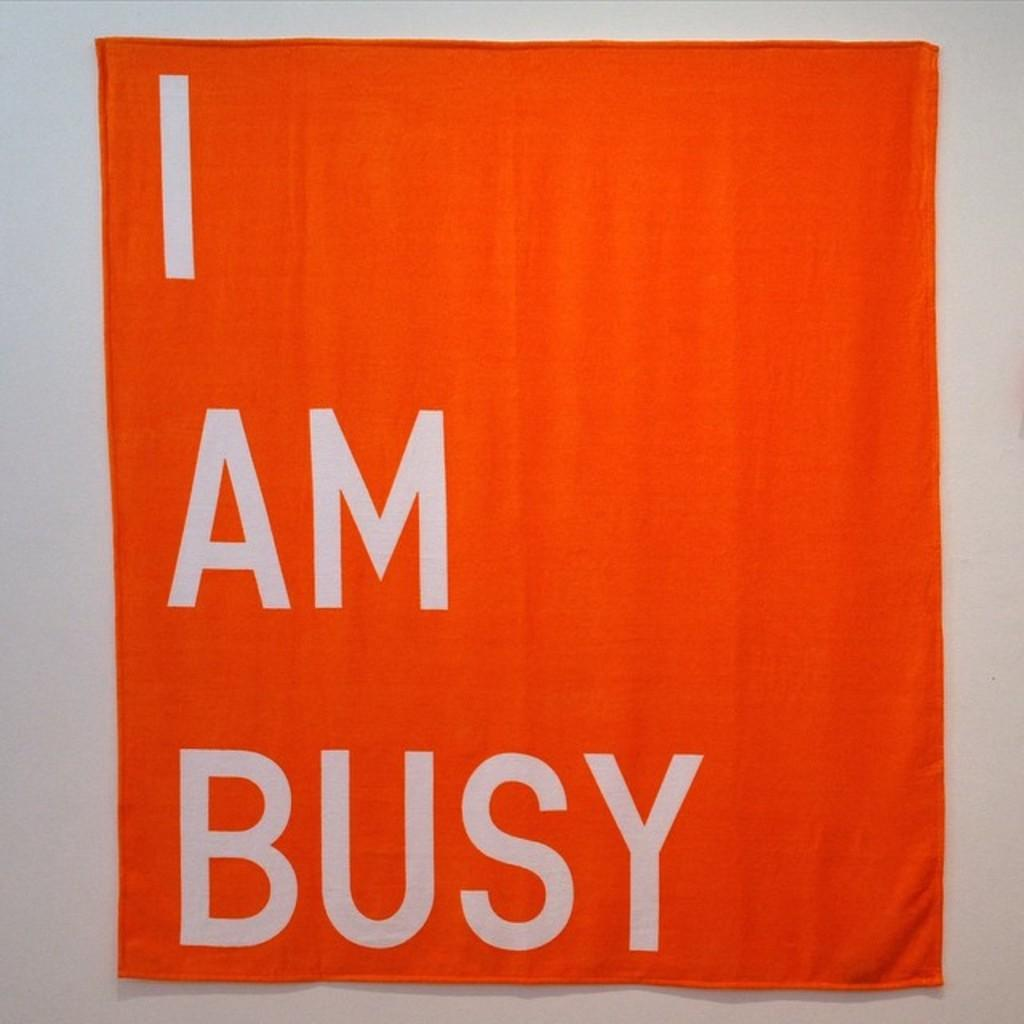<image>
Write a terse but informative summary of the picture. An orange towel with the words I AM BUSY printed on it. 